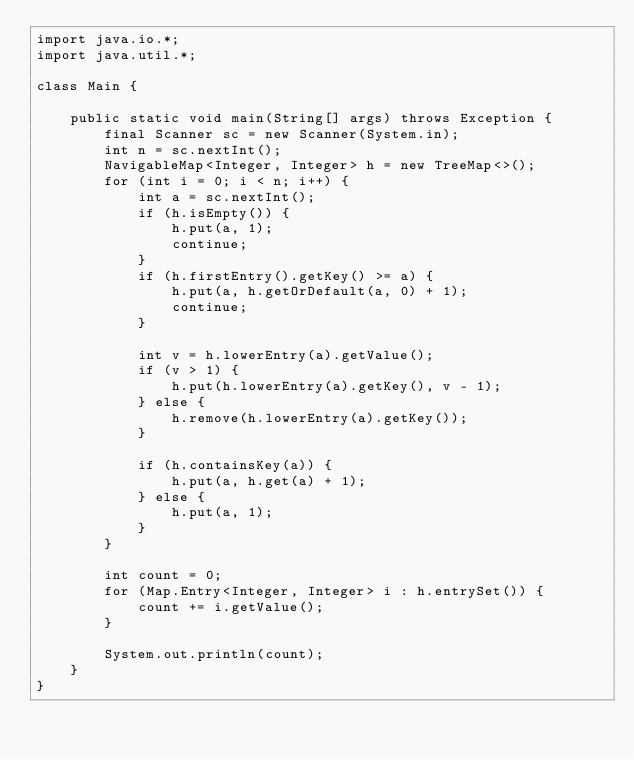<code> <loc_0><loc_0><loc_500><loc_500><_Java_>import java.io.*;
import java.util.*;

class Main {

	public static void main(String[] args) throws Exception {
		final Scanner sc = new Scanner(System.in);
		int n = sc.nextInt();
		NavigableMap<Integer, Integer> h = new TreeMap<>();
		for (int i = 0; i < n; i++) {
			int a = sc.nextInt();
			if (h.isEmpty()) {
				h.put(a, 1);
				continue;
			}
			if (h.firstEntry().getKey() >= a) {
				h.put(a, h.getOrDefault(a, 0) + 1);
				continue;
			}

			int v = h.lowerEntry(a).getValue();
			if (v > 1) {
				h.put(h.lowerEntry(a).getKey(), v - 1);
			} else {
				h.remove(h.lowerEntry(a).getKey());
			}

			if (h.containsKey(a)) {
				h.put(a, h.get(a) + 1);
			} else {
				h.put(a, 1);
			}
		}

		int count = 0;
		for (Map.Entry<Integer, Integer> i : h.entrySet()) {
			count += i.getValue();
		}

		System.out.println(count);
	}
}
</code> 